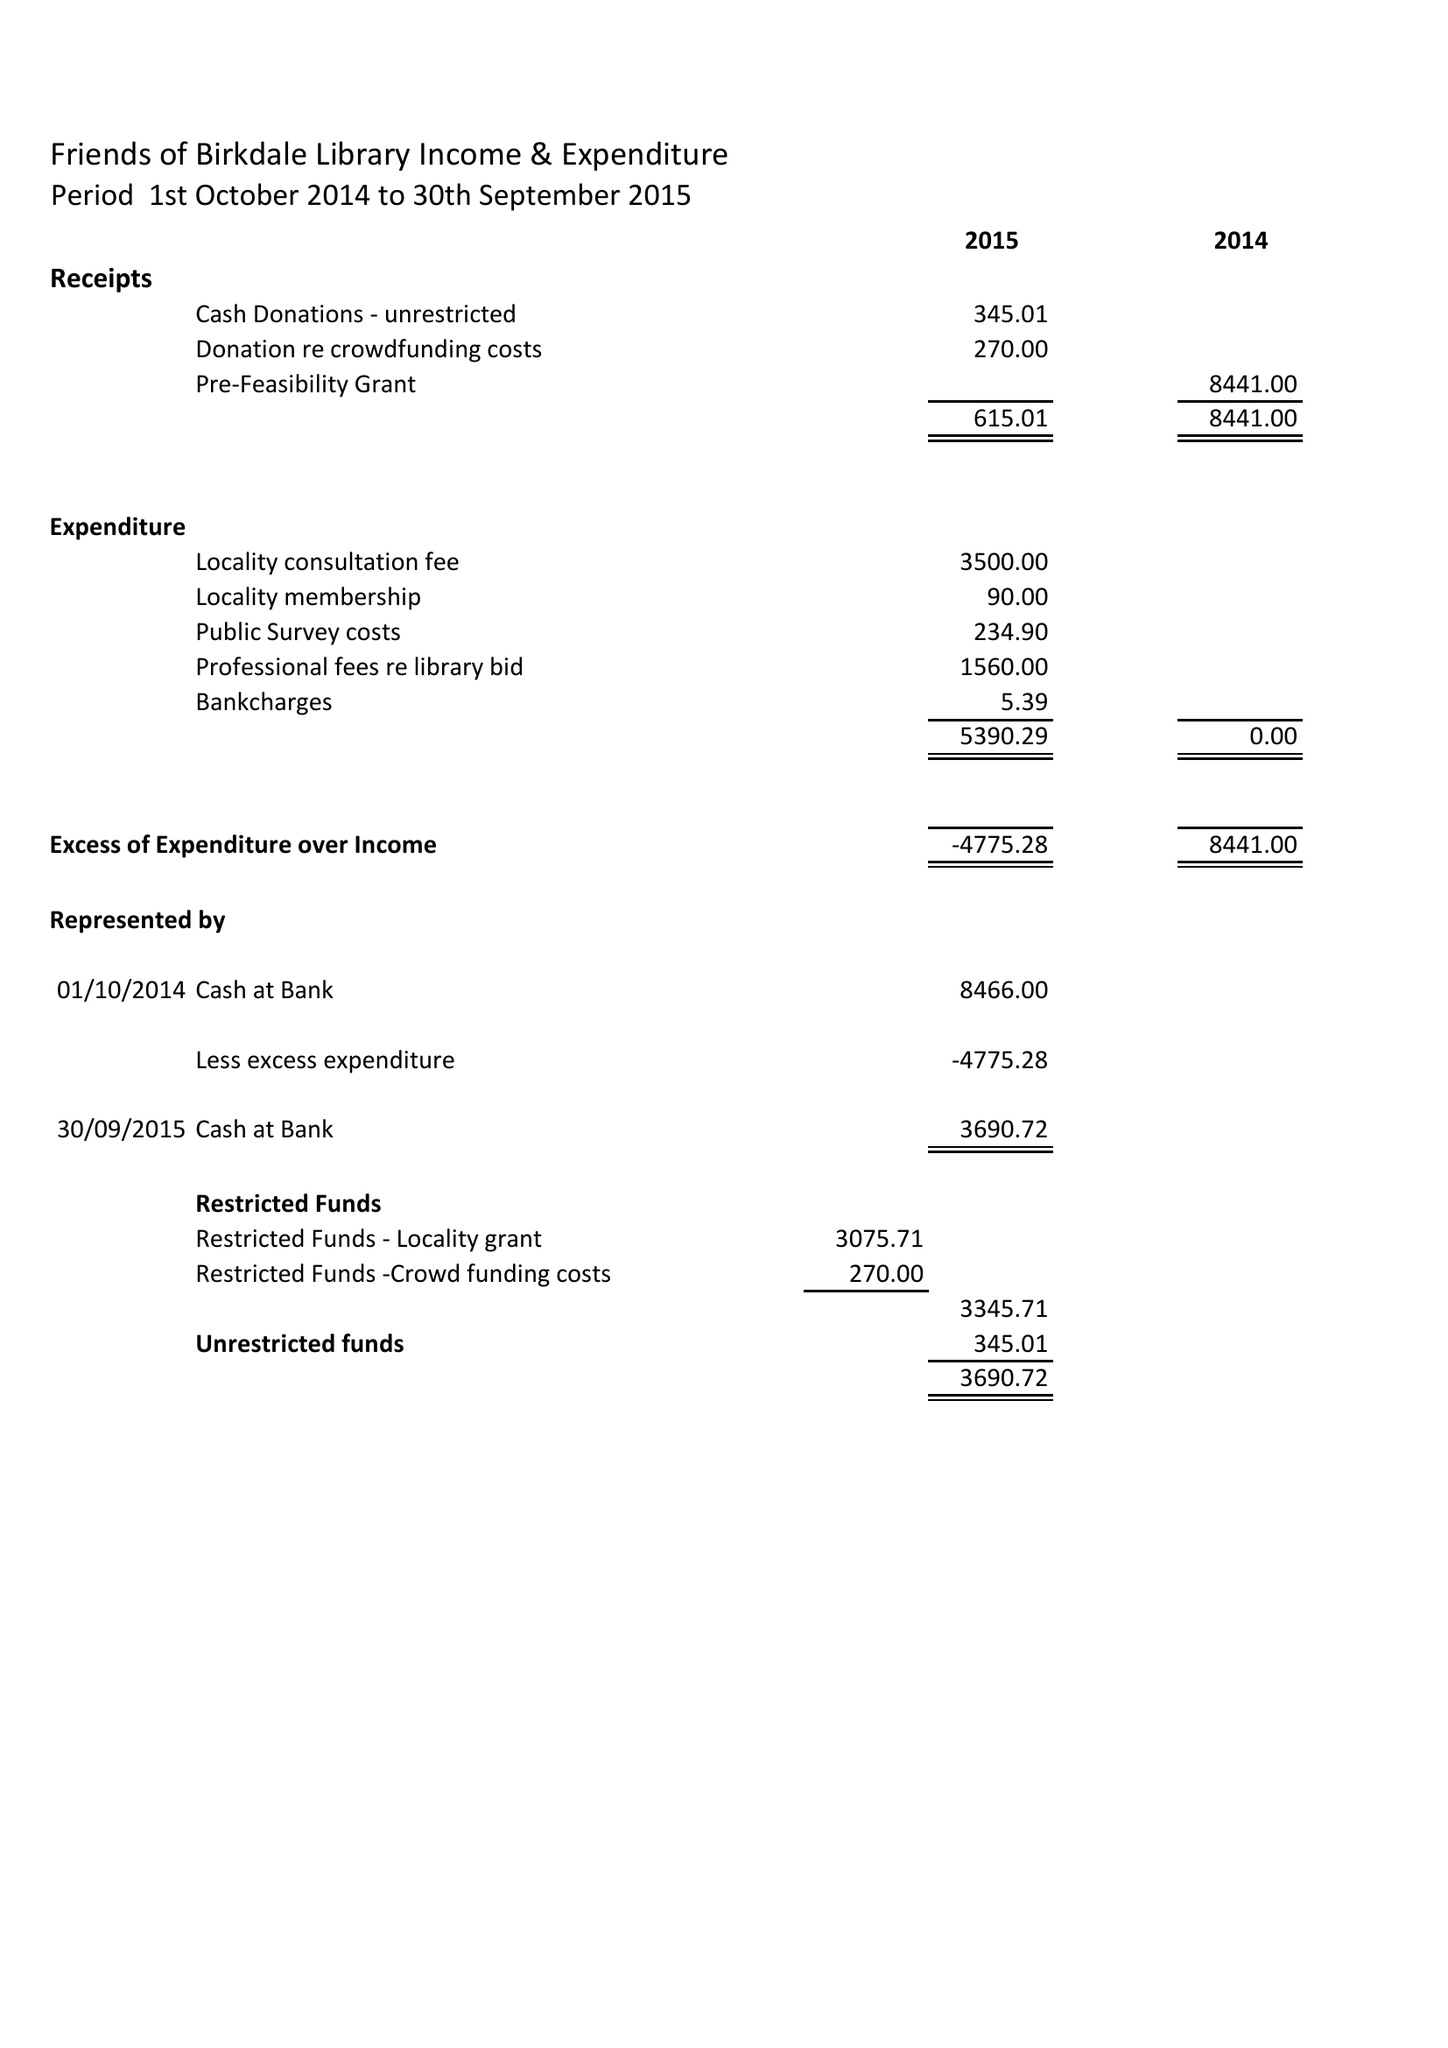What is the value for the spending_annually_in_british_pounds?
Answer the question using a single word or phrase. 5390.00 